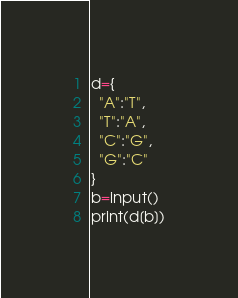<code> <loc_0><loc_0><loc_500><loc_500><_Python_>d={
  "A":"T",
  "T":"A",
  "C":"G",
  "G":"C"
}
b=input()
print(d[b])</code> 